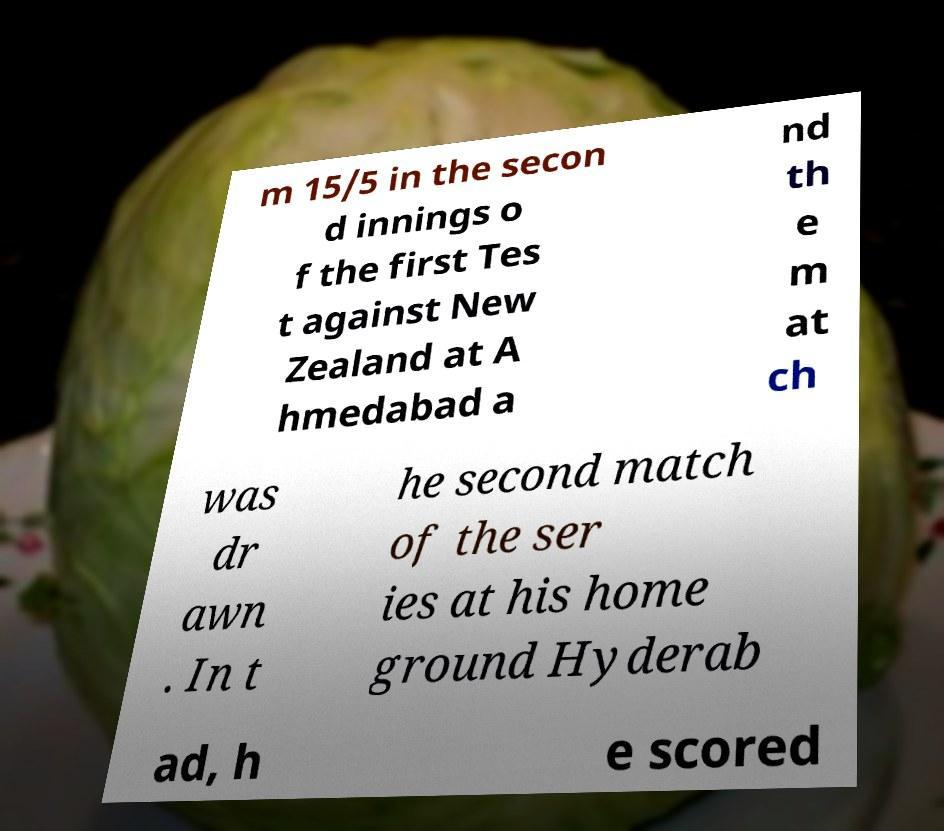Please identify and transcribe the text found in this image. m 15/5 in the secon d innings o f the first Tes t against New Zealand at A hmedabad a nd th e m at ch was dr awn . In t he second match of the ser ies at his home ground Hyderab ad, h e scored 